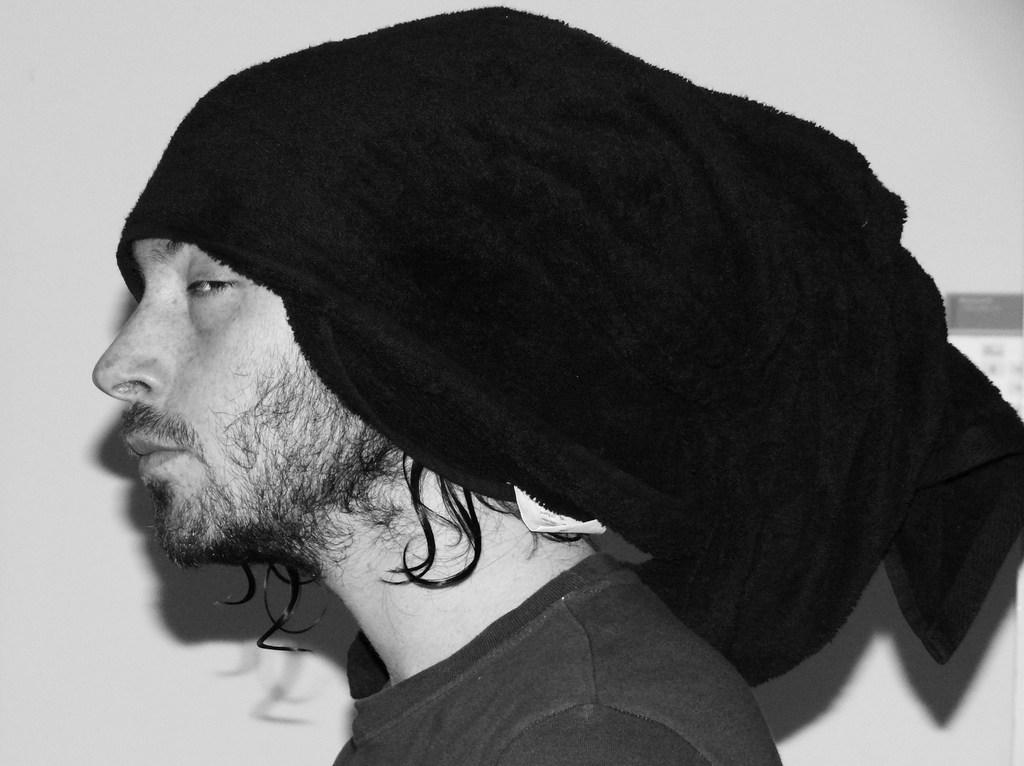Who or what is the main subject of the image? There is a person in the image. What can be seen in the background of the image? There is a wall in the background of the image. How many goldfish are swimming in the person's mouth in the image? There are no goldfish present in the image, and the person's mouth is not visible. 